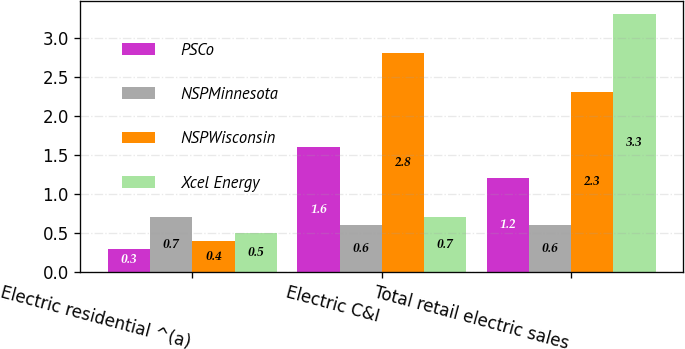Convert chart. <chart><loc_0><loc_0><loc_500><loc_500><stacked_bar_chart><ecel><fcel>Electric residential ^(a)<fcel>Electric C&I<fcel>Total retail electric sales<nl><fcel>PSCo<fcel>0.3<fcel>1.6<fcel>1.2<nl><fcel>NSPMinnesota<fcel>0.7<fcel>0.6<fcel>0.6<nl><fcel>NSPWisconsin<fcel>0.4<fcel>2.8<fcel>2.3<nl><fcel>Xcel Energy<fcel>0.5<fcel>0.7<fcel>3.3<nl></chart> 